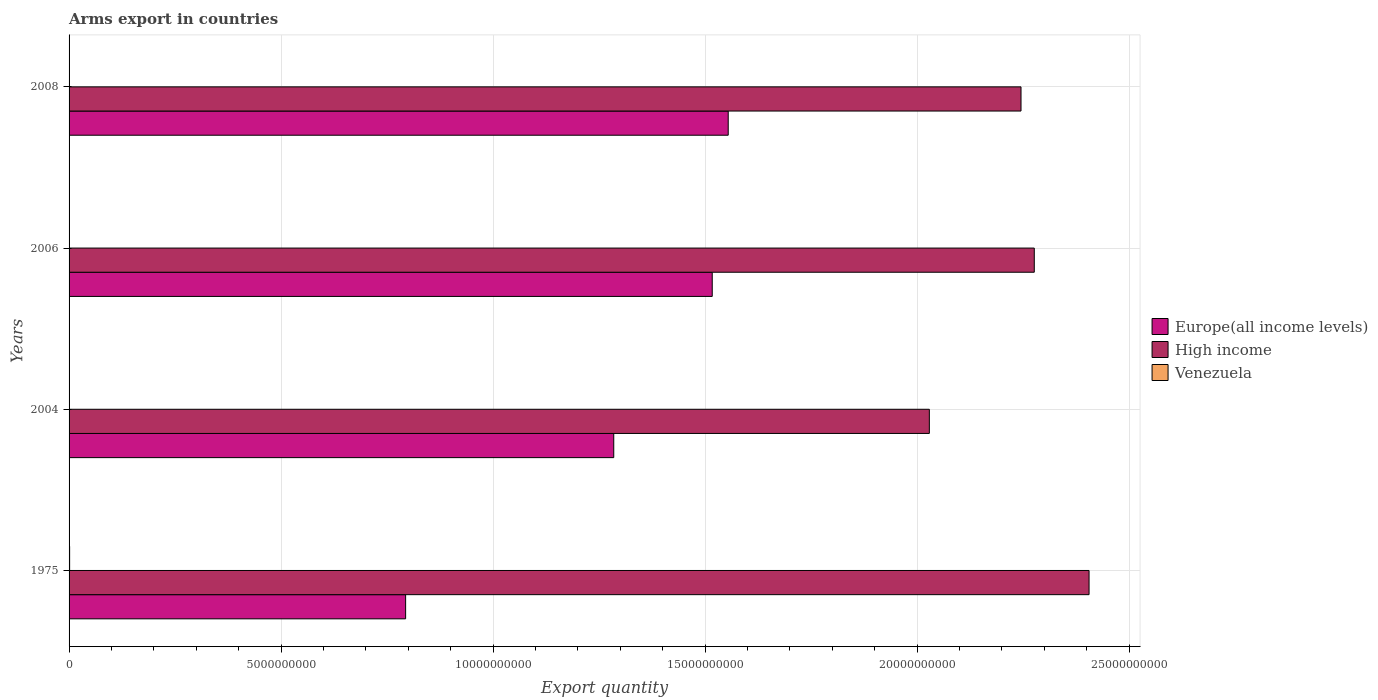How many groups of bars are there?
Give a very brief answer. 4. In how many cases, is the number of bars for a given year not equal to the number of legend labels?
Your answer should be very brief. 0. What is the total arms export in Europe(all income levels) in 2004?
Your answer should be compact. 1.28e+1. Across all years, what is the maximum total arms export in Venezuela?
Keep it short and to the point. 1.30e+07. Across all years, what is the minimum total arms export in Europe(all income levels)?
Your answer should be very brief. 7.94e+09. What is the total total arms export in Venezuela in the graph?
Ensure brevity in your answer.  2.40e+07. What is the difference between the total arms export in High income in 1975 and that in 2008?
Your answer should be compact. 1.60e+09. What is the difference between the total arms export in Europe(all income levels) in 2004 and the total arms export in High income in 2008?
Provide a short and direct response. -9.61e+09. In the year 1975, what is the difference between the total arms export in Venezuela and total arms export in Europe(all income levels)?
Provide a short and direct response. -7.92e+09. What is the ratio of the total arms export in Europe(all income levels) in 2004 to that in 2006?
Give a very brief answer. 0.85. Is the difference between the total arms export in Venezuela in 1975 and 2008 greater than the difference between the total arms export in Europe(all income levels) in 1975 and 2008?
Give a very brief answer. Yes. What is the difference between the highest and the second highest total arms export in Europe(all income levels)?
Provide a succinct answer. 3.77e+08. What is the difference between the highest and the lowest total arms export in High income?
Give a very brief answer. 3.77e+09. In how many years, is the total arms export in Venezuela greater than the average total arms export in Venezuela taken over all years?
Your answer should be very brief. 2. What does the 1st bar from the top in 2006 represents?
Make the answer very short. Venezuela. What does the 2nd bar from the bottom in 2006 represents?
Offer a terse response. High income. Are all the bars in the graph horizontal?
Give a very brief answer. Yes. How many years are there in the graph?
Give a very brief answer. 4. Does the graph contain grids?
Your answer should be very brief. Yes. Where does the legend appear in the graph?
Ensure brevity in your answer.  Center right. What is the title of the graph?
Your response must be concise. Arms export in countries. Does "Lesotho" appear as one of the legend labels in the graph?
Offer a very short reply. No. What is the label or title of the X-axis?
Provide a short and direct response. Export quantity. What is the Export quantity of Europe(all income levels) in 1975?
Provide a short and direct response. 7.94e+09. What is the Export quantity in High income in 1975?
Offer a very short reply. 2.41e+1. What is the Export quantity in Venezuela in 1975?
Offer a terse response. 1.30e+07. What is the Export quantity of Europe(all income levels) in 2004?
Keep it short and to the point. 1.28e+1. What is the Export quantity of High income in 2004?
Your response must be concise. 2.03e+1. What is the Export quantity in Venezuela in 2004?
Provide a succinct answer. 1.00e+06. What is the Export quantity in Europe(all income levels) in 2006?
Offer a terse response. 1.52e+1. What is the Export quantity of High income in 2006?
Your answer should be very brief. 2.28e+1. What is the Export quantity in Venezuela in 2006?
Provide a short and direct response. 7.00e+06. What is the Export quantity of Europe(all income levels) in 2008?
Keep it short and to the point. 1.55e+1. What is the Export quantity in High income in 2008?
Offer a terse response. 2.25e+1. What is the Export quantity in Venezuela in 2008?
Your answer should be very brief. 3.00e+06. Across all years, what is the maximum Export quantity of Europe(all income levels)?
Keep it short and to the point. 1.55e+1. Across all years, what is the maximum Export quantity of High income?
Your answer should be very brief. 2.41e+1. Across all years, what is the maximum Export quantity in Venezuela?
Provide a succinct answer. 1.30e+07. Across all years, what is the minimum Export quantity in Europe(all income levels)?
Offer a terse response. 7.94e+09. Across all years, what is the minimum Export quantity in High income?
Your answer should be very brief. 2.03e+1. What is the total Export quantity of Europe(all income levels) in the graph?
Keep it short and to the point. 5.15e+1. What is the total Export quantity of High income in the graph?
Your answer should be very brief. 8.96e+1. What is the total Export quantity of Venezuela in the graph?
Keep it short and to the point. 2.40e+07. What is the difference between the Export quantity in Europe(all income levels) in 1975 and that in 2004?
Keep it short and to the point. -4.91e+09. What is the difference between the Export quantity in High income in 1975 and that in 2004?
Ensure brevity in your answer.  3.77e+09. What is the difference between the Export quantity in Europe(all income levels) in 1975 and that in 2006?
Your response must be concise. -7.23e+09. What is the difference between the Export quantity of High income in 1975 and that in 2006?
Keep it short and to the point. 1.29e+09. What is the difference between the Export quantity in Venezuela in 1975 and that in 2006?
Ensure brevity in your answer.  6.00e+06. What is the difference between the Export quantity in Europe(all income levels) in 1975 and that in 2008?
Offer a terse response. -7.61e+09. What is the difference between the Export quantity of High income in 1975 and that in 2008?
Keep it short and to the point. 1.60e+09. What is the difference between the Export quantity of Europe(all income levels) in 2004 and that in 2006?
Your answer should be compact. -2.32e+09. What is the difference between the Export quantity in High income in 2004 and that in 2006?
Your answer should be compact. -2.48e+09. What is the difference between the Export quantity in Venezuela in 2004 and that in 2006?
Offer a very short reply. -6.00e+06. What is the difference between the Export quantity in Europe(all income levels) in 2004 and that in 2008?
Make the answer very short. -2.70e+09. What is the difference between the Export quantity of High income in 2004 and that in 2008?
Provide a short and direct response. -2.16e+09. What is the difference between the Export quantity in Venezuela in 2004 and that in 2008?
Provide a succinct answer. -2.00e+06. What is the difference between the Export quantity in Europe(all income levels) in 2006 and that in 2008?
Provide a short and direct response. -3.77e+08. What is the difference between the Export quantity in High income in 2006 and that in 2008?
Offer a very short reply. 3.13e+08. What is the difference between the Export quantity of Europe(all income levels) in 1975 and the Export quantity of High income in 2004?
Your response must be concise. -1.24e+1. What is the difference between the Export quantity in Europe(all income levels) in 1975 and the Export quantity in Venezuela in 2004?
Provide a short and direct response. 7.94e+09. What is the difference between the Export quantity of High income in 1975 and the Export quantity of Venezuela in 2004?
Offer a terse response. 2.41e+1. What is the difference between the Export quantity of Europe(all income levels) in 1975 and the Export quantity of High income in 2006?
Give a very brief answer. -1.48e+1. What is the difference between the Export quantity of Europe(all income levels) in 1975 and the Export quantity of Venezuela in 2006?
Your answer should be compact. 7.93e+09. What is the difference between the Export quantity in High income in 1975 and the Export quantity in Venezuela in 2006?
Offer a very short reply. 2.41e+1. What is the difference between the Export quantity of Europe(all income levels) in 1975 and the Export quantity of High income in 2008?
Keep it short and to the point. -1.45e+1. What is the difference between the Export quantity of Europe(all income levels) in 1975 and the Export quantity of Venezuela in 2008?
Provide a succinct answer. 7.94e+09. What is the difference between the Export quantity of High income in 1975 and the Export quantity of Venezuela in 2008?
Make the answer very short. 2.41e+1. What is the difference between the Export quantity in Europe(all income levels) in 2004 and the Export quantity in High income in 2006?
Make the answer very short. -9.92e+09. What is the difference between the Export quantity in Europe(all income levels) in 2004 and the Export quantity in Venezuela in 2006?
Your answer should be very brief. 1.28e+1. What is the difference between the Export quantity of High income in 2004 and the Export quantity of Venezuela in 2006?
Make the answer very short. 2.03e+1. What is the difference between the Export quantity in Europe(all income levels) in 2004 and the Export quantity in High income in 2008?
Give a very brief answer. -9.61e+09. What is the difference between the Export quantity of Europe(all income levels) in 2004 and the Export quantity of Venezuela in 2008?
Your answer should be compact. 1.28e+1. What is the difference between the Export quantity in High income in 2004 and the Export quantity in Venezuela in 2008?
Make the answer very short. 2.03e+1. What is the difference between the Export quantity of Europe(all income levels) in 2006 and the Export quantity of High income in 2008?
Give a very brief answer. -7.28e+09. What is the difference between the Export quantity in Europe(all income levels) in 2006 and the Export quantity in Venezuela in 2008?
Your answer should be very brief. 1.52e+1. What is the difference between the Export quantity in High income in 2006 and the Export quantity in Venezuela in 2008?
Offer a very short reply. 2.28e+1. What is the average Export quantity in Europe(all income levels) per year?
Provide a short and direct response. 1.29e+1. What is the average Export quantity of High income per year?
Your answer should be compact. 2.24e+1. In the year 1975, what is the difference between the Export quantity in Europe(all income levels) and Export quantity in High income?
Offer a terse response. -1.61e+1. In the year 1975, what is the difference between the Export quantity of Europe(all income levels) and Export quantity of Venezuela?
Give a very brief answer. 7.92e+09. In the year 1975, what is the difference between the Export quantity of High income and Export quantity of Venezuela?
Ensure brevity in your answer.  2.40e+1. In the year 2004, what is the difference between the Export quantity in Europe(all income levels) and Export quantity in High income?
Your answer should be very brief. -7.44e+09. In the year 2004, what is the difference between the Export quantity of Europe(all income levels) and Export quantity of Venezuela?
Make the answer very short. 1.28e+1. In the year 2004, what is the difference between the Export quantity in High income and Export quantity in Venezuela?
Offer a terse response. 2.03e+1. In the year 2006, what is the difference between the Export quantity of Europe(all income levels) and Export quantity of High income?
Offer a terse response. -7.60e+09. In the year 2006, what is the difference between the Export quantity in Europe(all income levels) and Export quantity in Venezuela?
Your answer should be very brief. 1.52e+1. In the year 2006, what is the difference between the Export quantity in High income and Export quantity in Venezuela?
Ensure brevity in your answer.  2.28e+1. In the year 2008, what is the difference between the Export quantity of Europe(all income levels) and Export quantity of High income?
Give a very brief answer. -6.91e+09. In the year 2008, what is the difference between the Export quantity of Europe(all income levels) and Export quantity of Venezuela?
Provide a succinct answer. 1.55e+1. In the year 2008, what is the difference between the Export quantity of High income and Export quantity of Venezuela?
Ensure brevity in your answer.  2.24e+1. What is the ratio of the Export quantity of Europe(all income levels) in 1975 to that in 2004?
Your response must be concise. 0.62. What is the ratio of the Export quantity of High income in 1975 to that in 2004?
Give a very brief answer. 1.19. What is the ratio of the Export quantity in Venezuela in 1975 to that in 2004?
Provide a succinct answer. 13. What is the ratio of the Export quantity of Europe(all income levels) in 1975 to that in 2006?
Your answer should be compact. 0.52. What is the ratio of the Export quantity of High income in 1975 to that in 2006?
Keep it short and to the point. 1.06. What is the ratio of the Export quantity in Venezuela in 1975 to that in 2006?
Make the answer very short. 1.86. What is the ratio of the Export quantity of Europe(all income levels) in 1975 to that in 2008?
Provide a short and direct response. 0.51. What is the ratio of the Export quantity of High income in 1975 to that in 2008?
Offer a very short reply. 1.07. What is the ratio of the Export quantity in Venezuela in 1975 to that in 2008?
Keep it short and to the point. 4.33. What is the ratio of the Export quantity in Europe(all income levels) in 2004 to that in 2006?
Your response must be concise. 0.85. What is the ratio of the Export quantity in High income in 2004 to that in 2006?
Provide a short and direct response. 0.89. What is the ratio of the Export quantity of Venezuela in 2004 to that in 2006?
Keep it short and to the point. 0.14. What is the ratio of the Export quantity in Europe(all income levels) in 2004 to that in 2008?
Make the answer very short. 0.83. What is the ratio of the Export quantity of High income in 2004 to that in 2008?
Offer a very short reply. 0.9. What is the ratio of the Export quantity in Venezuela in 2004 to that in 2008?
Provide a short and direct response. 0.33. What is the ratio of the Export quantity in Europe(all income levels) in 2006 to that in 2008?
Offer a very short reply. 0.98. What is the ratio of the Export quantity of High income in 2006 to that in 2008?
Your answer should be compact. 1.01. What is the ratio of the Export quantity in Venezuela in 2006 to that in 2008?
Provide a succinct answer. 2.33. What is the difference between the highest and the second highest Export quantity in Europe(all income levels)?
Offer a terse response. 3.77e+08. What is the difference between the highest and the second highest Export quantity in High income?
Give a very brief answer. 1.29e+09. What is the difference between the highest and the second highest Export quantity in Venezuela?
Give a very brief answer. 6.00e+06. What is the difference between the highest and the lowest Export quantity of Europe(all income levels)?
Make the answer very short. 7.61e+09. What is the difference between the highest and the lowest Export quantity of High income?
Your answer should be compact. 3.77e+09. What is the difference between the highest and the lowest Export quantity of Venezuela?
Give a very brief answer. 1.20e+07. 